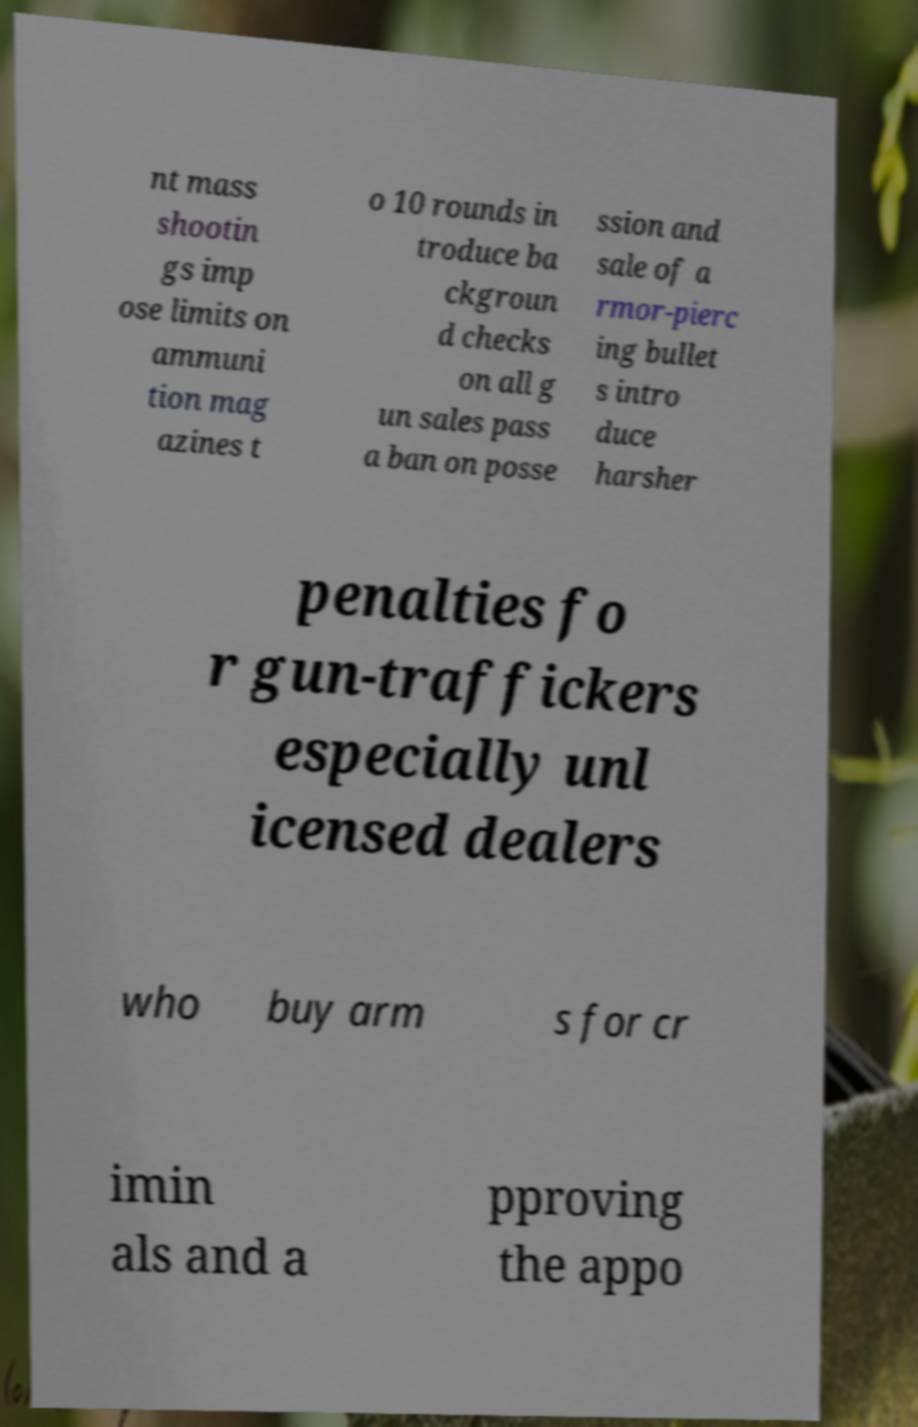Can you accurately transcribe the text from the provided image for me? nt mass shootin gs imp ose limits on ammuni tion mag azines t o 10 rounds in troduce ba ckgroun d checks on all g un sales pass a ban on posse ssion and sale of a rmor-pierc ing bullet s intro duce harsher penalties fo r gun-traffickers especially unl icensed dealers who buy arm s for cr imin als and a pproving the appo 